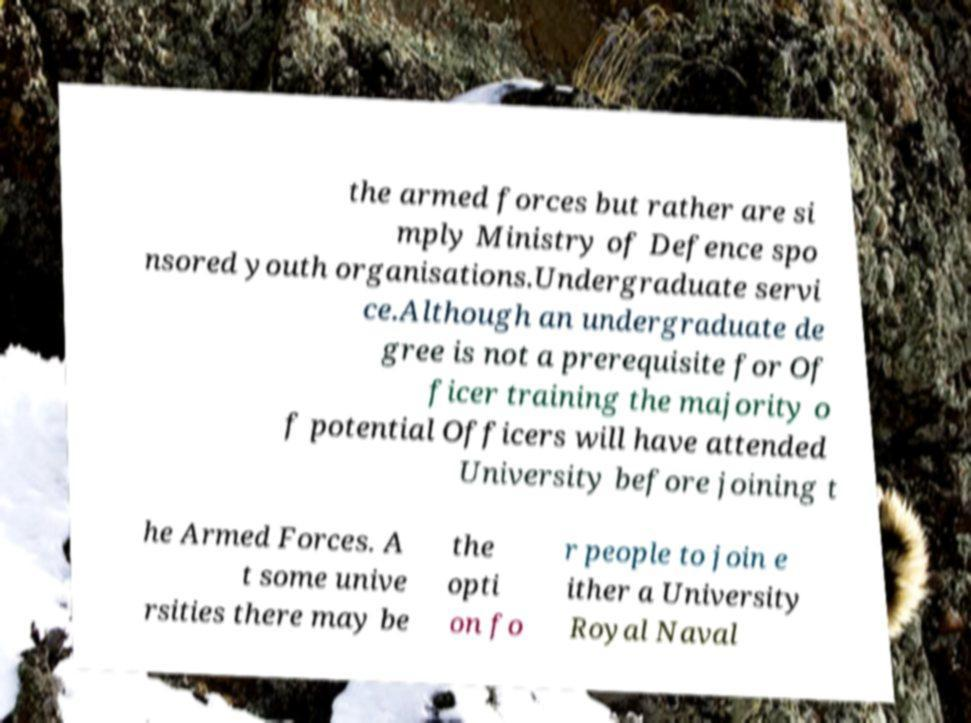Please read and relay the text visible in this image. What does it say? the armed forces but rather are si mply Ministry of Defence spo nsored youth organisations.Undergraduate servi ce.Although an undergraduate de gree is not a prerequisite for Of ficer training the majority o f potential Officers will have attended University before joining t he Armed Forces. A t some unive rsities there may be the opti on fo r people to join e ither a University Royal Naval 